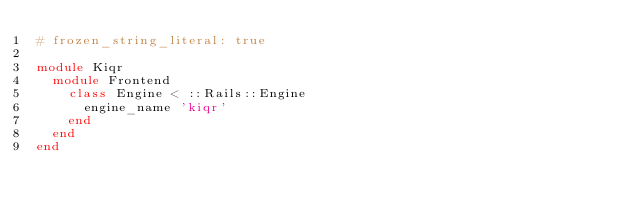Convert code to text. <code><loc_0><loc_0><loc_500><loc_500><_Ruby_># frozen_string_literal: true

module Kiqr
  module Frontend
    class Engine < ::Rails::Engine
      engine_name 'kiqr'
    end
  end
end
</code> 